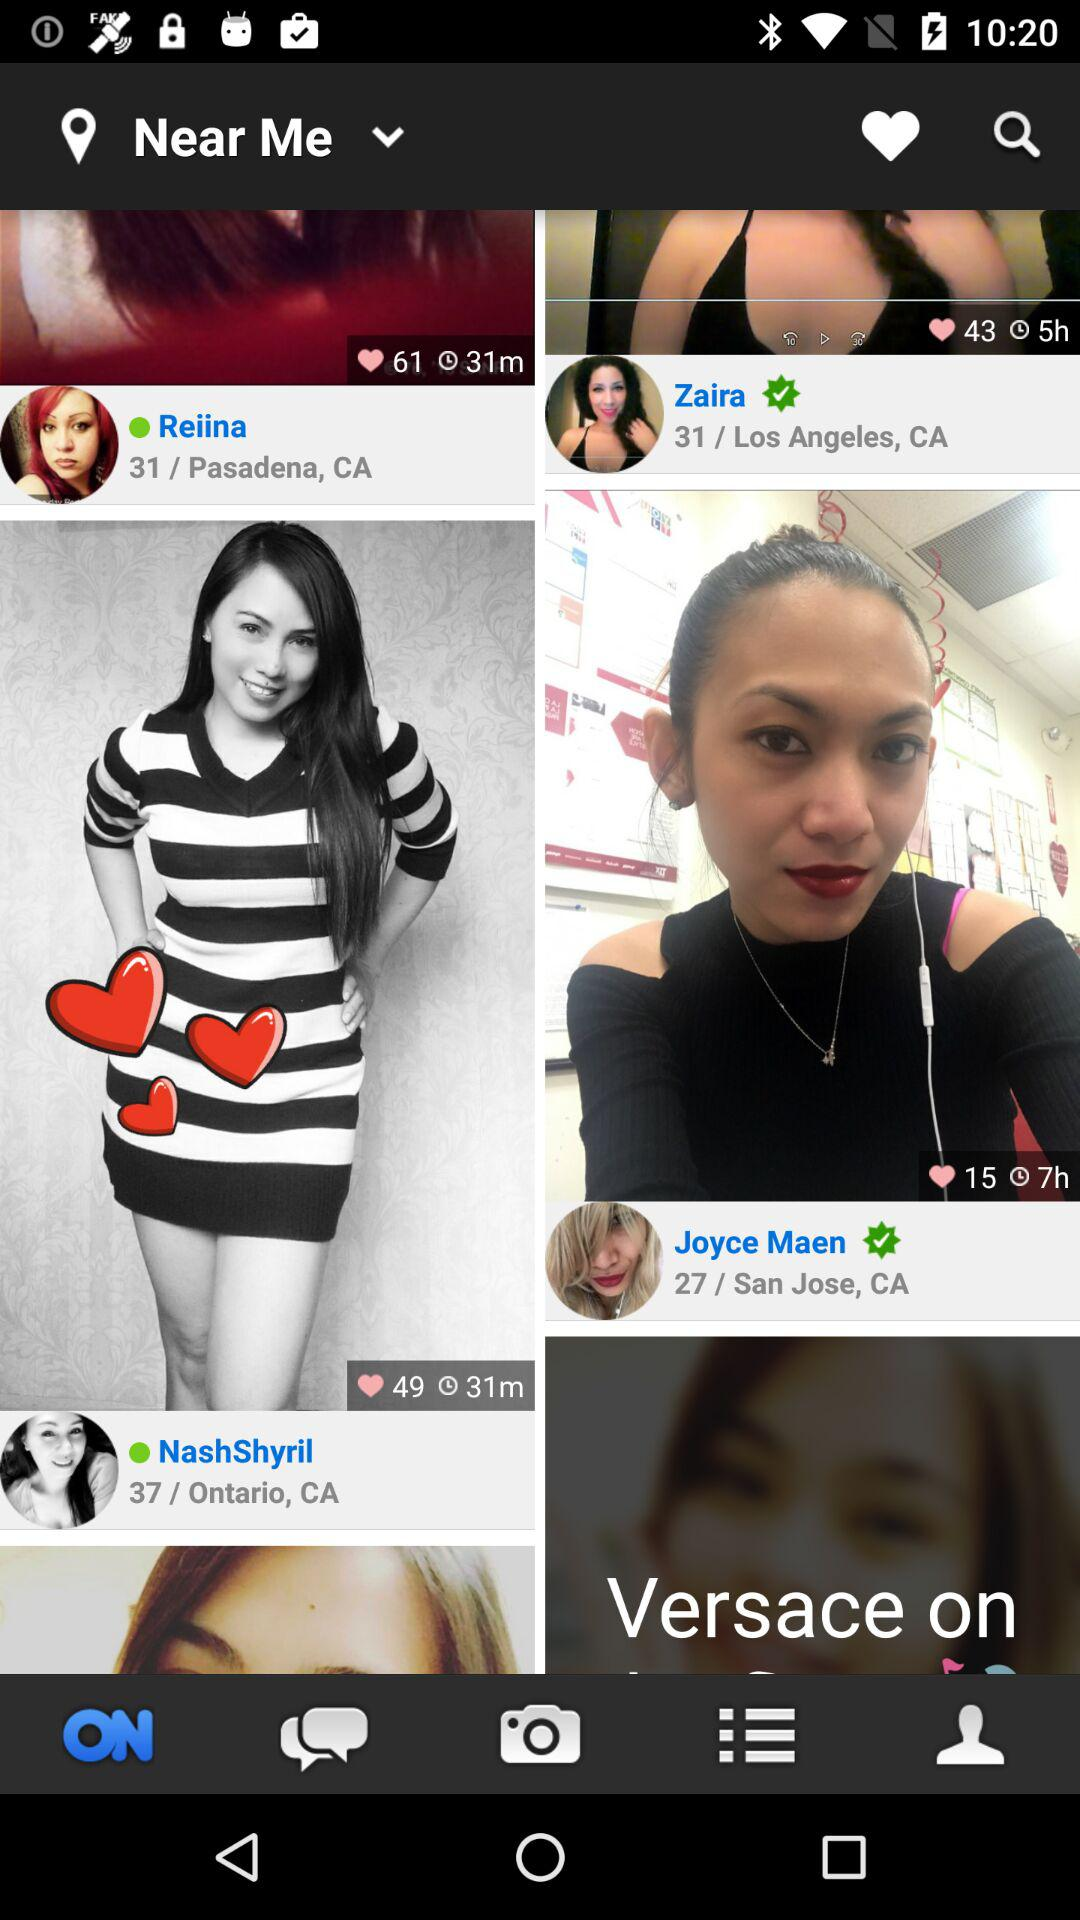How many years old is Joyce Maen? Joyce Maen is 27 years old. 